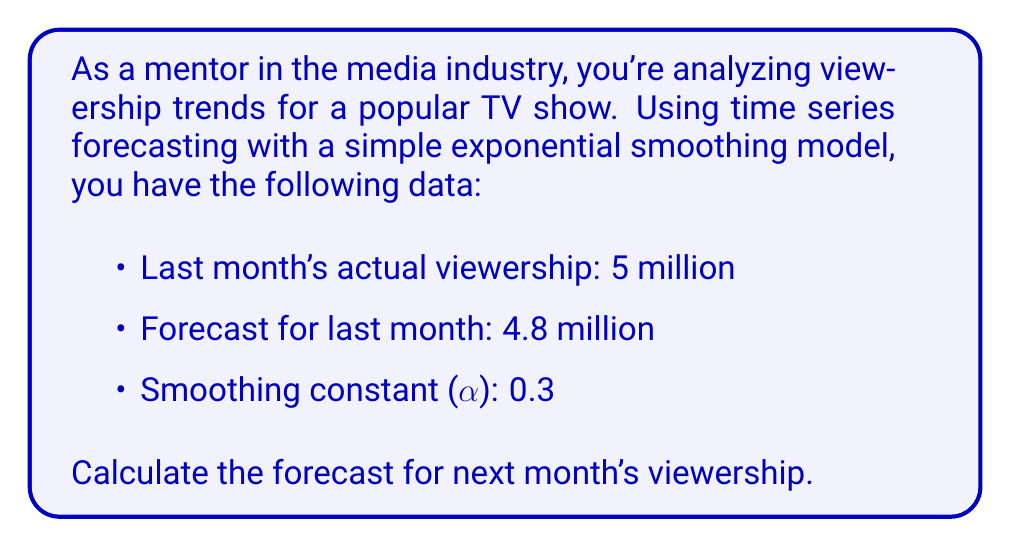Could you help me with this problem? To solve this problem, we'll use the simple exponential smoothing formula:

$$F_{t+1} = \alpha Y_t + (1-\alpha)F_t$$

Where:
$F_{t+1}$ is the forecast for the next period
$\alpha$ is the smoothing constant
$Y_t$ is the actual value for the current period
$F_t$ is the forecast for the current period

Given:
$Y_t = 5$ million (last month's actual viewership)
$F_t = 4.8$ million (forecast for last month)
$\alpha = 0.3$

Step 1: Plug the values into the formula
$$F_{t+1} = 0.3 \times 5 + (1-0.3) \times 4.8$$

Step 2: Simplify
$$F_{t+1} = 1.5 + 0.7 \times 4.8$$
$$F_{t+1} = 1.5 + 3.36$$

Step 3: Calculate the final result
$$F_{t+1} = 4.86$$

Therefore, the forecast for next month's viewership is 4.86 million.
Answer: 4.86 million viewers 